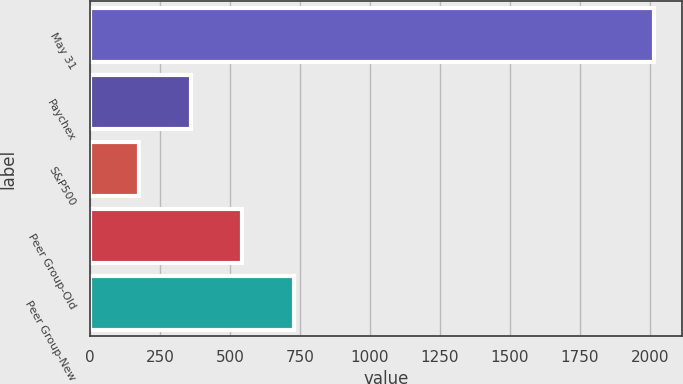<chart> <loc_0><loc_0><loc_500><loc_500><bar_chart><fcel>May 31<fcel>Paychex<fcel>S&P500<fcel>Peer Group-Old<fcel>Peer Group-New<nl><fcel>2016<fcel>358.51<fcel>174.34<fcel>542.68<fcel>726.85<nl></chart> 